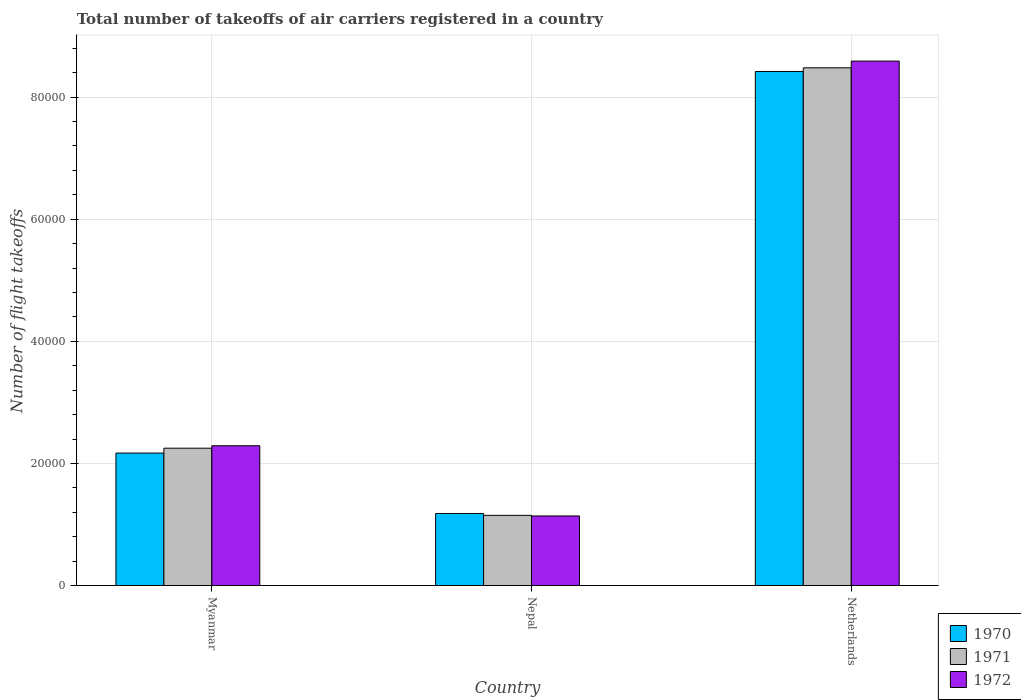How many bars are there on the 2nd tick from the right?
Offer a terse response. 3. What is the label of the 2nd group of bars from the left?
Offer a terse response. Nepal. In how many cases, is the number of bars for a given country not equal to the number of legend labels?
Offer a very short reply. 0. What is the total number of flight takeoffs in 1970 in Netherlands?
Provide a short and direct response. 8.42e+04. Across all countries, what is the maximum total number of flight takeoffs in 1971?
Provide a short and direct response. 8.48e+04. Across all countries, what is the minimum total number of flight takeoffs in 1972?
Offer a terse response. 1.14e+04. In which country was the total number of flight takeoffs in 1972 minimum?
Give a very brief answer. Nepal. What is the total total number of flight takeoffs in 1970 in the graph?
Offer a terse response. 1.18e+05. What is the difference between the total number of flight takeoffs in 1970 in Myanmar and that in Netherlands?
Offer a very short reply. -6.25e+04. What is the difference between the total number of flight takeoffs in 1972 in Myanmar and the total number of flight takeoffs in 1971 in Netherlands?
Your response must be concise. -6.19e+04. What is the average total number of flight takeoffs in 1970 per country?
Your answer should be compact. 3.92e+04. What is the ratio of the total number of flight takeoffs in 1970 in Myanmar to that in Netherlands?
Your answer should be very brief. 0.26. What is the difference between the highest and the second highest total number of flight takeoffs in 1970?
Your answer should be compact. 7.24e+04. What is the difference between the highest and the lowest total number of flight takeoffs in 1970?
Your answer should be very brief. 7.24e+04. Is the sum of the total number of flight takeoffs in 1971 in Myanmar and Netherlands greater than the maximum total number of flight takeoffs in 1972 across all countries?
Give a very brief answer. Yes. What does the 3rd bar from the left in Myanmar represents?
Offer a very short reply. 1972. What does the 3rd bar from the right in Nepal represents?
Ensure brevity in your answer.  1970. Is it the case that in every country, the sum of the total number of flight takeoffs in 1972 and total number of flight takeoffs in 1971 is greater than the total number of flight takeoffs in 1970?
Give a very brief answer. Yes. Are all the bars in the graph horizontal?
Offer a terse response. No. What is the difference between two consecutive major ticks on the Y-axis?
Offer a terse response. 2.00e+04. Where does the legend appear in the graph?
Ensure brevity in your answer.  Bottom right. What is the title of the graph?
Provide a succinct answer. Total number of takeoffs of air carriers registered in a country. What is the label or title of the X-axis?
Your answer should be compact. Country. What is the label or title of the Y-axis?
Provide a succinct answer. Number of flight takeoffs. What is the Number of flight takeoffs in 1970 in Myanmar?
Provide a succinct answer. 2.17e+04. What is the Number of flight takeoffs of 1971 in Myanmar?
Make the answer very short. 2.25e+04. What is the Number of flight takeoffs of 1972 in Myanmar?
Provide a succinct answer. 2.29e+04. What is the Number of flight takeoffs of 1970 in Nepal?
Ensure brevity in your answer.  1.18e+04. What is the Number of flight takeoffs of 1971 in Nepal?
Keep it short and to the point. 1.15e+04. What is the Number of flight takeoffs in 1972 in Nepal?
Your answer should be very brief. 1.14e+04. What is the Number of flight takeoffs in 1970 in Netherlands?
Provide a short and direct response. 8.42e+04. What is the Number of flight takeoffs in 1971 in Netherlands?
Offer a very short reply. 8.48e+04. What is the Number of flight takeoffs in 1972 in Netherlands?
Provide a short and direct response. 8.59e+04. Across all countries, what is the maximum Number of flight takeoffs of 1970?
Your answer should be very brief. 8.42e+04. Across all countries, what is the maximum Number of flight takeoffs of 1971?
Offer a very short reply. 8.48e+04. Across all countries, what is the maximum Number of flight takeoffs in 1972?
Your response must be concise. 8.59e+04. Across all countries, what is the minimum Number of flight takeoffs in 1970?
Give a very brief answer. 1.18e+04. Across all countries, what is the minimum Number of flight takeoffs in 1971?
Keep it short and to the point. 1.15e+04. Across all countries, what is the minimum Number of flight takeoffs in 1972?
Give a very brief answer. 1.14e+04. What is the total Number of flight takeoffs of 1970 in the graph?
Your response must be concise. 1.18e+05. What is the total Number of flight takeoffs in 1971 in the graph?
Provide a succinct answer. 1.19e+05. What is the total Number of flight takeoffs in 1972 in the graph?
Give a very brief answer. 1.20e+05. What is the difference between the Number of flight takeoffs in 1970 in Myanmar and that in Nepal?
Keep it short and to the point. 9900. What is the difference between the Number of flight takeoffs of 1971 in Myanmar and that in Nepal?
Provide a short and direct response. 1.10e+04. What is the difference between the Number of flight takeoffs in 1972 in Myanmar and that in Nepal?
Your answer should be very brief. 1.15e+04. What is the difference between the Number of flight takeoffs of 1970 in Myanmar and that in Netherlands?
Your answer should be very brief. -6.25e+04. What is the difference between the Number of flight takeoffs of 1971 in Myanmar and that in Netherlands?
Your response must be concise. -6.23e+04. What is the difference between the Number of flight takeoffs of 1972 in Myanmar and that in Netherlands?
Keep it short and to the point. -6.30e+04. What is the difference between the Number of flight takeoffs in 1970 in Nepal and that in Netherlands?
Keep it short and to the point. -7.24e+04. What is the difference between the Number of flight takeoffs of 1971 in Nepal and that in Netherlands?
Make the answer very short. -7.33e+04. What is the difference between the Number of flight takeoffs in 1972 in Nepal and that in Netherlands?
Make the answer very short. -7.45e+04. What is the difference between the Number of flight takeoffs of 1970 in Myanmar and the Number of flight takeoffs of 1971 in Nepal?
Provide a short and direct response. 1.02e+04. What is the difference between the Number of flight takeoffs of 1970 in Myanmar and the Number of flight takeoffs of 1972 in Nepal?
Keep it short and to the point. 1.03e+04. What is the difference between the Number of flight takeoffs in 1971 in Myanmar and the Number of flight takeoffs in 1972 in Nepal?
Make the answer very short. 1.11e+04. What is the difference between the Number of flight takeoffs of 1970 in Myanmar and the Number of flight takeoffs of 1971 in Netherlands?
Your answer should be very brief. -6.31e+04. What is the difference between the Number of flight takeoffs of 1970 in Myanmar and the Number of flight takeoffs of 1972 in Netherlands?
Provide a succinct answer. -6.42e+04. What is the difference between the Number of flight takeoffs in 1971 in Myanmar and the Number of flight takeoffs in 1972 in Netherlands?
Your answer should be compact. -6.34e+04. What is the difference between the Number of flight takeoffs in 1970 in Nepal and the Number of flight takeoffs in 1971 in Netherlands?
Your answer should be very brief. -7.30e+04. What is the difference between the Number of flight takeoffs of 1970 in Nepal and the Number of flight takeoffs of 1972 in Netherlands?
Your answer should be compact. -7.41e+04. What is the difference between the Number of flight takeoffs of 1971 in Nepal and the Number of flight takeoffs of 1972 in Netherlands?
Ensure brevity in your answer.  -7.44e+04. What is the average Number of flight takeoffs in 1970 per country?
Make the answer very short. 3.92e+04. What is the average Number of flight takeoffs in 1971 per country?
Your response must be concise. 3.96e+04. What is the average Number of flight takeoffs in 1972 per country?
Your response must be concise. 4.01e+04. What is the difference between the Number of flight takeoffs of 1970 and Number of flight takeoffs of 1971 in Myanmar?
Give a very brief answer. -800. What is the difference between the Number of flight takeoffs in 1970 and Number of flight takeoffs in 1972 in Myanmar?
Your answer should be very brief. -1200. What is the difference between the Number of flight takeoffs of 1971 and Number of flight takeoffs of 1972 in Myanmar?
Provide a short and direct response. -400. What is the difference between the Number of flight takeoffs of 1970 and Number of flight takeoffs of 1971 in Nepal?
Offer a very short reply. 300. What is the difference between the Number of flight takeoffs in 1971 and Number of flight takeoffs in 1972 in Nepal?
Your answer should be very brief. 100. What is the difference between the Number of flight takeoffs in 1970 and Number of flight takeoffs in 1971 in Netherlands?
Provide a succinct answer. -600. What is the difference between the Number of flight takeoffs in 1970 and Number of flight takeoffs in 1972 in Netherlands?
Give a very brief answer. -1700. What is the difference between the Number of flight takeoffs in 1971 and Number of flight takeoffs in 1972 in Netherlands?
Provide a succinct answer. -1100. What is the ratio of the Number of flight takeoffs in 1970 in Myanmar to that in Nepal?
Give a very brief answer. 1.84. What is the ratio of the Number of flight takeoffs in 1971 in Myanmar to that in Nepal?
Your response must be concise. 1.96. What is the ratio of the Number of flight takeoffs of 1972 in Myanmar to that in Nepal?
Provide a short and direct response. 2.01. What is the ratio of the Number of flight takeoffs of 1970 in Myanmar to that in Netherlands?
Provide a short and direct response. 0.26. What is the ratio of the Number of flight takeoffs of 1971 in Myanmar to that in Netherlands?
Offer a very short reply. 0.27. What is the ratio of the Number of flight takeoffs of 1972 in Myanmar to that in Netherlands?
Provide a succinct answer. 0.27. What is the ratio of the Number of flight takeoffs of 1970 in Nepal to that in Netherlands?
Offer a very short reply. 0.14. What is the ratio of the Number of flight takeoffs of 1971 in Nepal to that in Netherlands?
Your response must be concise. 0.14. What is the ratio of the Number of flight takeoffs in 1972 in Nepal to that in Netherlands?
Make the answer very short. 0.13. What is the difference between the highest and the second highest Number of flight takeoffs in 1970?
Offer a terse response. 6.25e+04. What is the difference between the highest and the second highest Number of flight takeoffs of 1971?
Offer a very short reply. 6.23e+04. What is the difference between the highest and the second highest Number of flight takeoffs of 1972?
Offer a very short reply. 6.30e+04. What is the difference between the highest and the lowest Number of flight takeoffs in 1970?
Offer a very short reply. 7.24e+04. What is the difference between the highest and the lowest Number of flight takeoffs in 1971?
Your answer should be compact. 7.33e+04. What is the difference between the highest and the lowest Number of flight takeoffs of 1972?
Keep it short and to the point. 7.45e+04. 